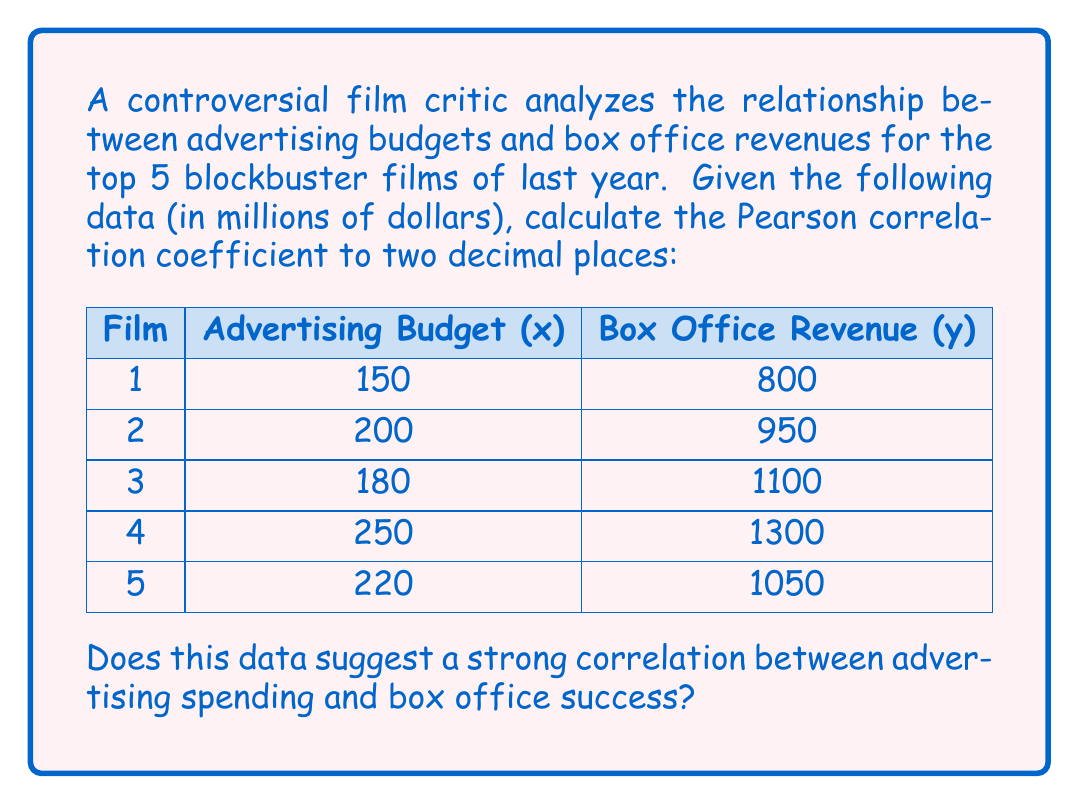Could you help me with this problem? To calculate the Pearson correlation coefficient (r), we'll use the formula:

$$ r = \frac{n\sum xy - \sum x \sum y}{\sqrt{[n\sum x^2 - (\sum x)^2][n\sum y^2 - (\sum y)^2]}} $$

Step 1: Calculate necessary sums:
$\sum x = 150 + 200 + 180 + 250 + 220 = 1000$
$\sum y = 800 + 950 + 1100 + 1300 + 1050 = 5200$
$\sum xy = (150)(800) + (200)(950) + (180)(1100) + (250)(1300) + (220)(1050) = 1,075,000$
$\sum x^2 = 150^2 + 200^2 + 180^2 + 250^2 + 220^2 = 206,000$
$\sum y^2 = 800^2 + 950^2 + 1100^2 + 1300^2 + 1050^2 = 5,585,000$
$n = 5$

Step 2: Plug values into the formula:

$$ r = \frac{5(1,075,000) - (1000)(5200)}{\sqrt{[5(206,000) - (1000)^2][5(5,585,000) - (5200)^2]}} $$

Step 3: Calculate:
$$ r = \frac{5,375,000 - 5,200,000}{\sqrt{(30,000)(425,000)}} = \frac{175,000}{112,694.28} \approx 0.8738 $$

Step 4: Round to two decimal places: 0.87

This result suggests a strong positive correlation between advertising budgets and box office revenues for these blockbuster films.
Answer: 0.87 